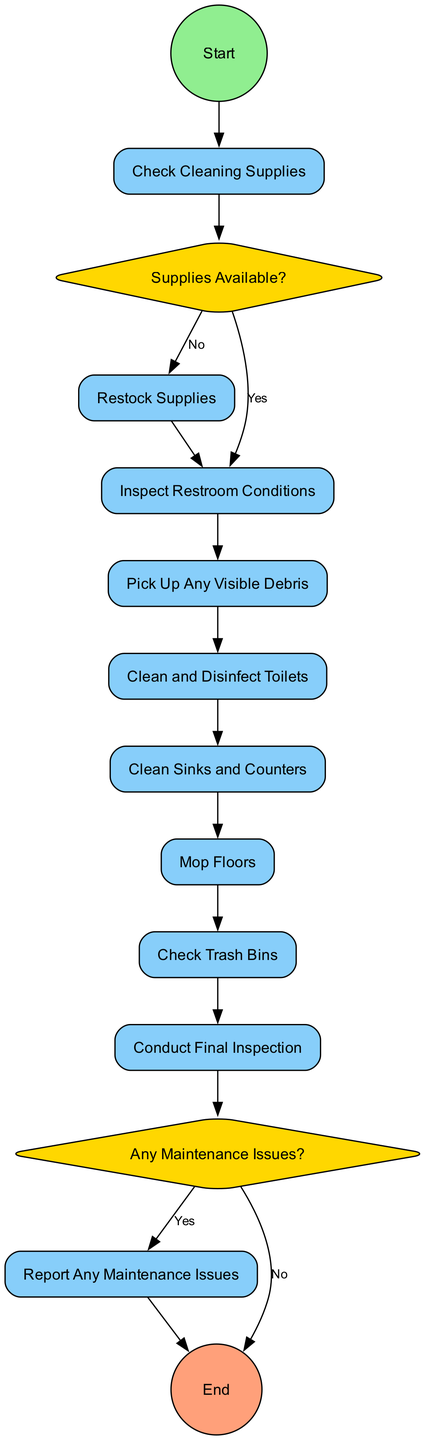What is the first task in the cleaning routine? The diagram indicates that the first task is "Check Cleaning Supplies," which is the first node following the "Start" event.
Answer: Check Cleaning Supplies How many tasks are involved in the restroom cleaning process? By counting the number of tasks listed in the diagram, there are seven tasks: Check Cleaning Supplies, Inspect Restroom Conditions, Pick Up Any Visible Debris, Clean and Disinfect Toilets, Clean Sinks and Counters, Mop Floors, and Check Trash Bins.
Answer: Seven What happens if supplies are not available? The flow diagram shows that if supplies are not available, the next step is to "Restock Supplies" before moving to the inspection of conditions.
Answer: Restock Supplies What is the last task before the cleaning routine concludes? The final task before reaching the end of the routine is "Conduct Final Inspection," which allows for a thorough check of cleanliness and supply adequacy.
Answer: Conduct Final Inspection Are maintenance issues reported during the cleaning routine? Yes, after the final inspection, if there are any maintenance issues, the cleaning staff is instructed to "Report Any Maintenance Issues."
Answer: Yes What shape represents the decision points in the diagram? The decision points in the diagram, labeled as "exclusiveGateway," are represented by diamond shapes, indicating a choice or conditional pathway in the flow.
Answer: Diamond What is the label used for the endpoint of the cleaning routine? The endpoint of the cleaning routine is labeled as "End," which signifies the completion of the entire cleaning and inspection process.
Answer: End What is checked after cleaning the floors? After mopping the floors, the next task is to "Check Trash Bins" to ensure that the waste receptacles are not overflowing.
Answer: Check Trash Bins Is there a task dedicated to cleaning the sinks? Yes, there is a specific task called "Clean Sinks and Counters," which includes the cleaning of sinks, counters, and mirrors.
Answer: Clean Sinks and Counters 